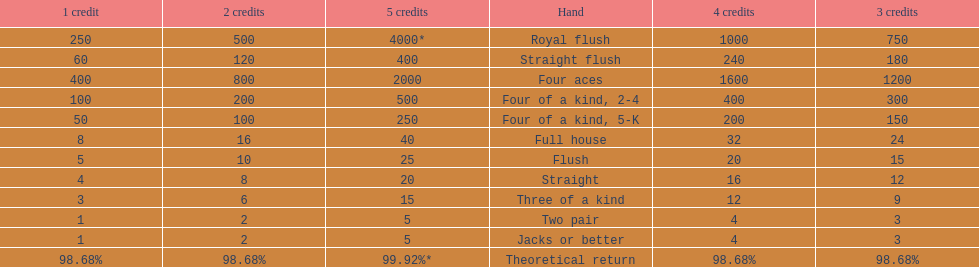The number of credits returned for a one credit bet on a royal flush are. 250. 